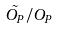Convert formula to latex. <formula><loc_0><loc_0><loc_500><loc_500>\tilde { O _ { P } } / O _ { P }</formula> 